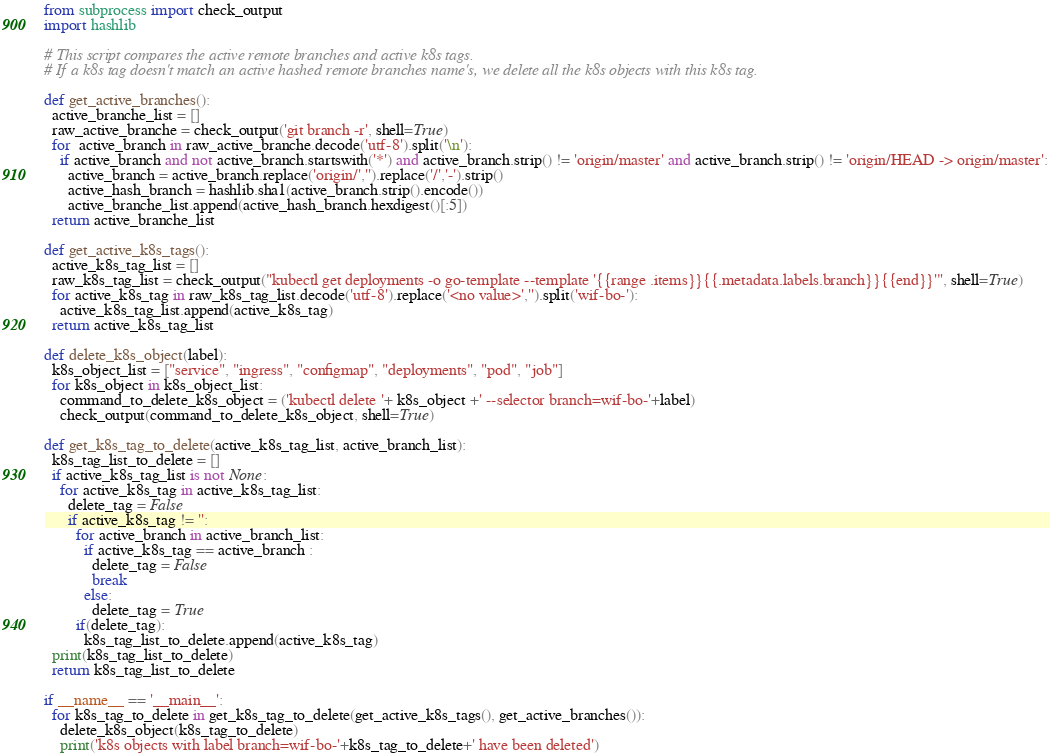<code> <loc_0><loc_0><loc_500><loc_500><_Python_>from subprocess import check_output
import hashlib

# This script compares the active remote branches and active k8s tags.
# If a k8s tag doesn't match an active hashed remote branches name's, we delete all the k8s objects with this k8s tag.

def get_active_branches():
  active_branche_list = []
  raw_active_branche = check_output('git branch -r', shell=True)
  for  active_branch in raw_active_branche.decode('utf-8').split('\n'):
    if active_branch and not active_branch.startswith('*') and active_branch.strip() != 'origin/master' and active_branch.strip() != 'origin/HEAD -> origin/master':
      active_branch = active_branch.replace('origin/','').replace('/','-').strip()
      active_hash_branch = hashlib.sha1(active_branch.strip().encode())
      active_branche_list.append(active_hash_branch.hexdigest()[:5])
  return active_branche_list

def get_active_k8s_tags():
  active_k8s_tag_list = []
  raw_k8s_tag_list = check_output("kubectl get deployments -o go-template --template '{{range .items}}{{.metadata.labels.branch}}{{end}}'", shell=True)
  for active_k8s_tag in raw_k8s_tag_list.decode('utf-8').replace('<no value>','').split('wif-bo-'):
    active_k8s_tag_list.append(active_k8s_tag)
  return active_k8s_tag_list

def delete_k8s_object(label):
  k8s_object_list = ["service", "ingress", "configmap", "deployments", "pod", "job"]
  for k8s_object in k8s_object_list:
    command_to_delete_k8s_object = ('kubectl delete '+ k8s_object +' --selector branch=wif-bo-'+label)
    check_output(command_to_delete_k8s_object, shell=True)

def get_k8s_tag_to_delete(active_k8s_tag_list, active_branch_list):
  k8s_tag_list_to_delete = []
  if active_k8s_tag_list is not None:
    for active_k8s_tag in active_k8s_tag_list:
      delete_tag = False
      if active_k8s_tag != '':
        for active_branch in active_branch_list:
          if active_k8s_tag == active_branch :
            delete_tag = False
            break
          else:
            delete_tag = True
        if(delete_tag):
          k8s_tag_list_to_delete.append(active_k8s_tag)
  print(k8s_tag_list_to_delete)
  return k8s_tag_list_to_delete

if __name__ == '__main__':
  for k8s_tag_to_delete in get_k8s_tag_to_delete(get_active_k8s_tags(), get_active_branches()):
    delete_k8s_object(k8s_tag_to_delete)
    print('k8s objects with label branch=wif-bo-'+k8s_tag_to_delete+' have been deleted')
</code> 